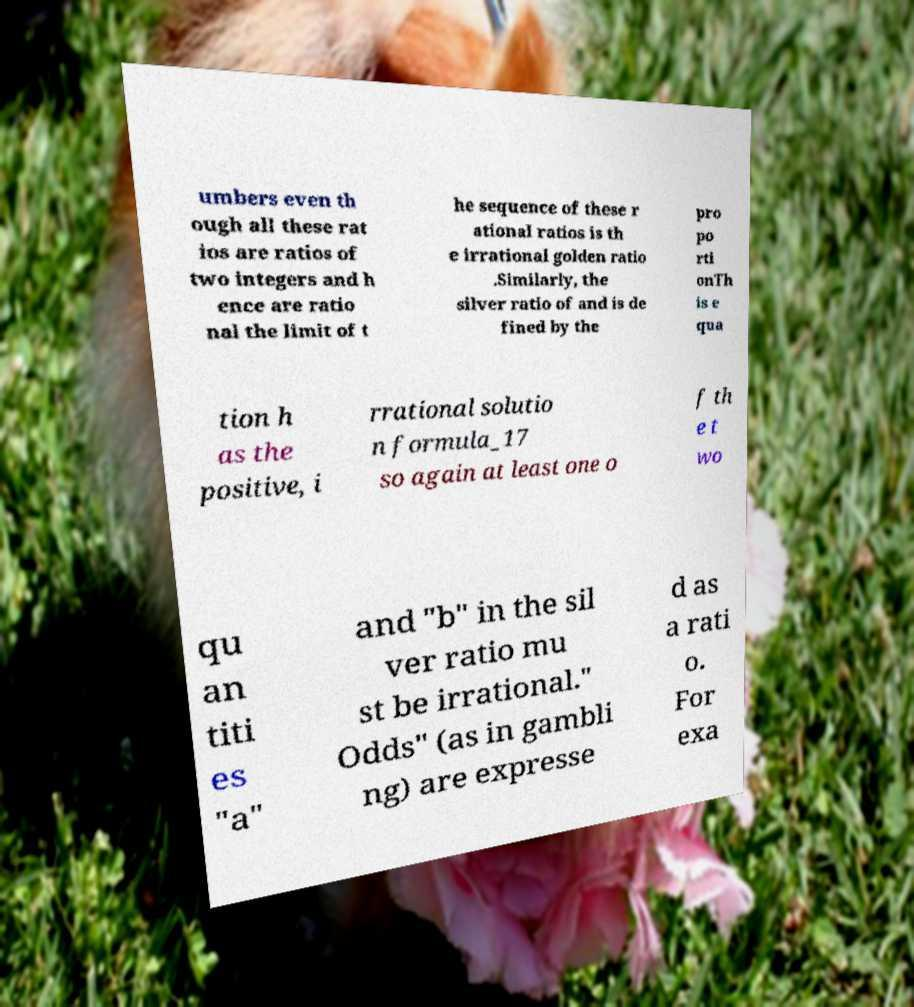Please identify and transcribe the text found in this image. umbers even th ough all these rat ios are ratios of two integers and h ence are ratio nal the limit of t he sequence of these r ational ratios is th e irrational golden ratio .Similarly, the silver ratio of and is de fined by the pro po rti onTh is e qua tion h as the positive, i rrational solutio n formula_17 so again at least one o f th e t wo qu an titi es "a" and "b" in the sil ver ratio mu st be irrational." Odds" (as in gambli ng) are expresse d as a rati o. For exa 